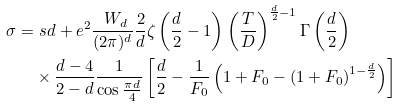<formula> <loc_0><loc_0><loc_500><loc_500>\sigma = & \ s d + e ^ { 2 } \frac { \ W _ { d } } { ( 2 \pi ) ^ { d } } \frac { 2 } { d } \zeta \left ( \frac { d } { 2 } - 1 \right ) \left ( \frac { T } { D } \right ) ^ { \frac { d } { 2 } - 1 } \Gamma \left ( \frac { d } { 2 } \right ) \\ & \times \frac { d - 4 } { 2 - d } \frac { 1 } { \cos \frac { \pi d } { 4 } } \left [ \frac { d } { 2 } - \frac { 1 } { F _ { 0 } } \left ( 1 + F _ { 0 } - \left ( 1 + F _ { 0 } \right ) ^ { 1 - \frac { d } { 2 } } \right ) \right ]</formula> 